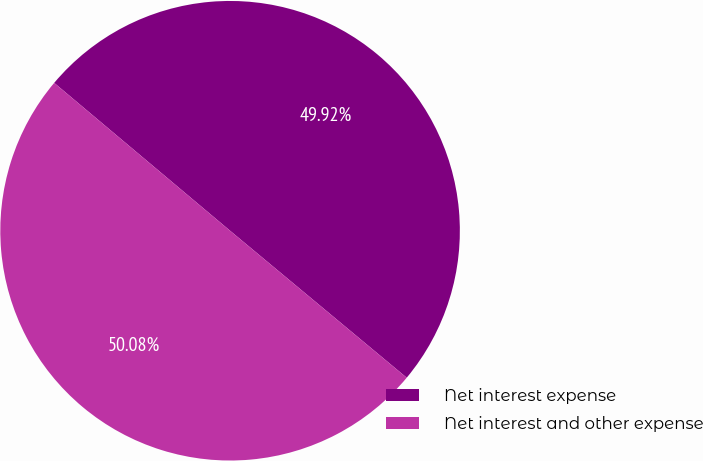Convert chart to OTSL. <chart><loc_0><loc_0><loc_500><loc_500><pie_chart><fcel>Net interest expense<fcel>Net interest and other expense<nl><fcel>49.92%<fcel>50.08%<nl></chart> 